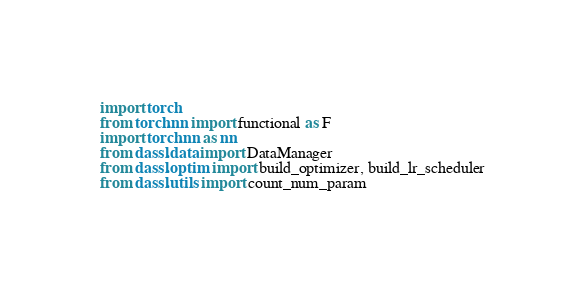<code> <loc_0><loc_0><loc_500><loc_500><_Python_>import torch
from torch.nn import functional as F
import torch.nn as nn
from dassl.data import DataManager
from dassl.optim import build_optimizer, build_lr_scheduler
from dassl.utils import count_num_param</code> 